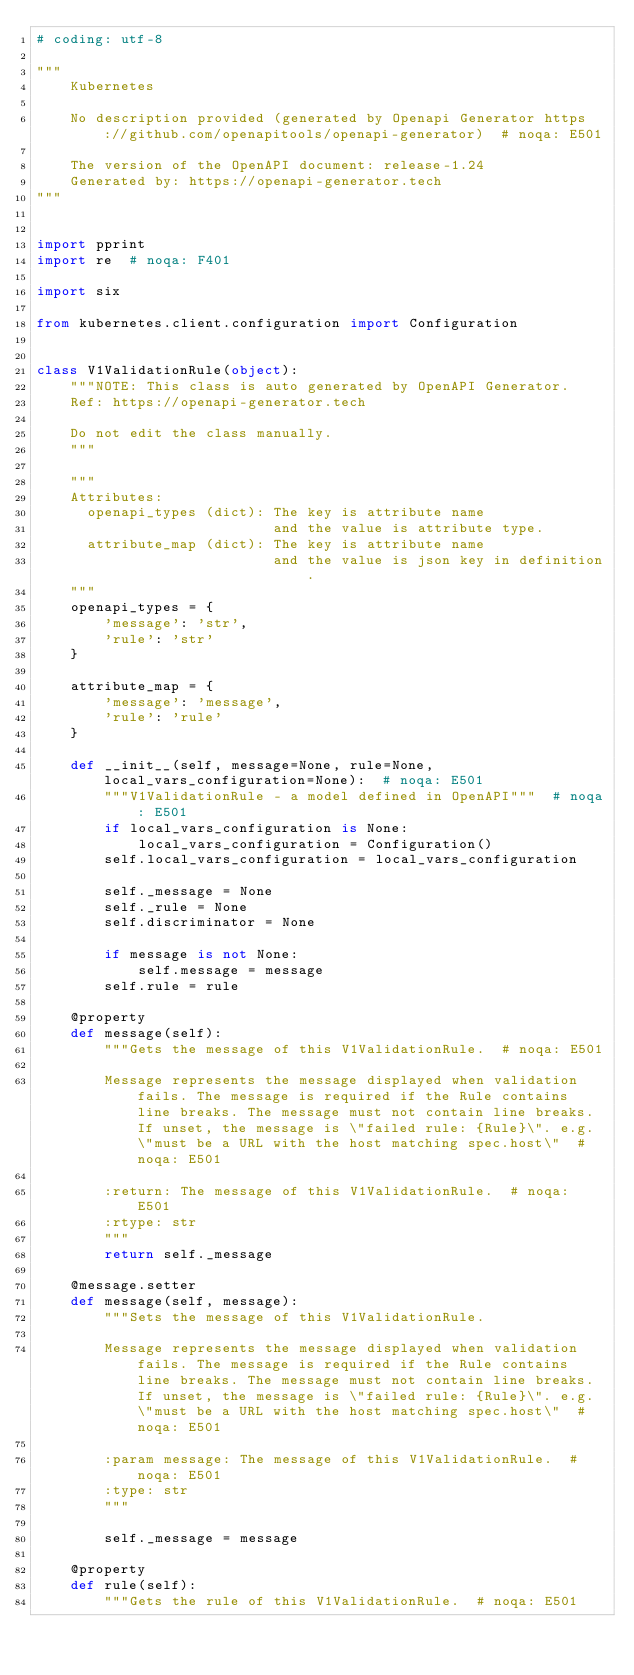<code> <loc_0><loc_0><loc_500><loc_500><_Python_># coding: utf-8

"""
    Kubernetes

    No description provided (generated by Openapi Generator https://github.com/openapitools/openapi-generator)  # noqa: E501

    The version of the OpenAPI document: release-1.24
    Generated by: https://openapi-generator.tech
"""


import pprint
import re  # noqa: F401

import six

from kubernetes.client.configuration import Configuration


class V1ValidationRule(object):
    """NOTE: This class is auto generated by OpenAPI Generator.
    Ref: https://openapi-generator.tech

    Do not edit the class manually.
    """

    """
    Attributes:
      openapi_types (dict): The key is attribute name
                            and the value is attribute type.
      attribute_map (dict): The key is attribute name
                            and the value is json key in definition.
    """
    openapi_types = {
        'message': 'str',
        'rule': 'str'
    }

    attribute_map = {
        'message': 'message',
        'rule': 'rule'
    }

    def __init__(self, message=None, rule=None, local_vars_configuration=None):  # noqa: E501
        """V1ValidationRule - a model defined in OpenAPI"""  # noqa: E501
        if local_vars_configuration is None:
            local_vars_configuration = Configuration()
        self.local_vars_configuration = local_vars_configuration

        self._message = None
        self._rule = None
        self.discriminator = None

        if message is not None:
            self.message = message
        self.rule = rule

    @property
    def message(self):
        """Gets the message of this V1ValidationRule.  # noqa: E501

        Message represents the message displayed when validation fails. The message is required if the Rule contains line breaks. The message must not contain line breaks. If unset, the message is \"failed rule: {Rule}\". e.g. \"must be a URL with the host matching spec.host\"  # noqa: E501

        :return: The message of this V1ValidationRule.  # noqa: E501
        :rtype: str
        """
        return self._message

    @message.setter
    def message(self, message):
        """Sets the message of this V1ValidationRule.

        Message represents the message displayed when validation fails. The message is required if the Rule contains line breaks. The message must not contain line breaks. If unset, the message is \"failed rule: {Rule}\". e.g. \"must be a URL with the host matching spec.host\"  # noqa: E501

        :param message: The message of this V1ValidationRule.  # noqa: E501
        :type: str
        """

        self._message = message

    @property
    def rule(self):
        """Gets the rule of this V1ValidationRule.  # noqa: E501
</code> 